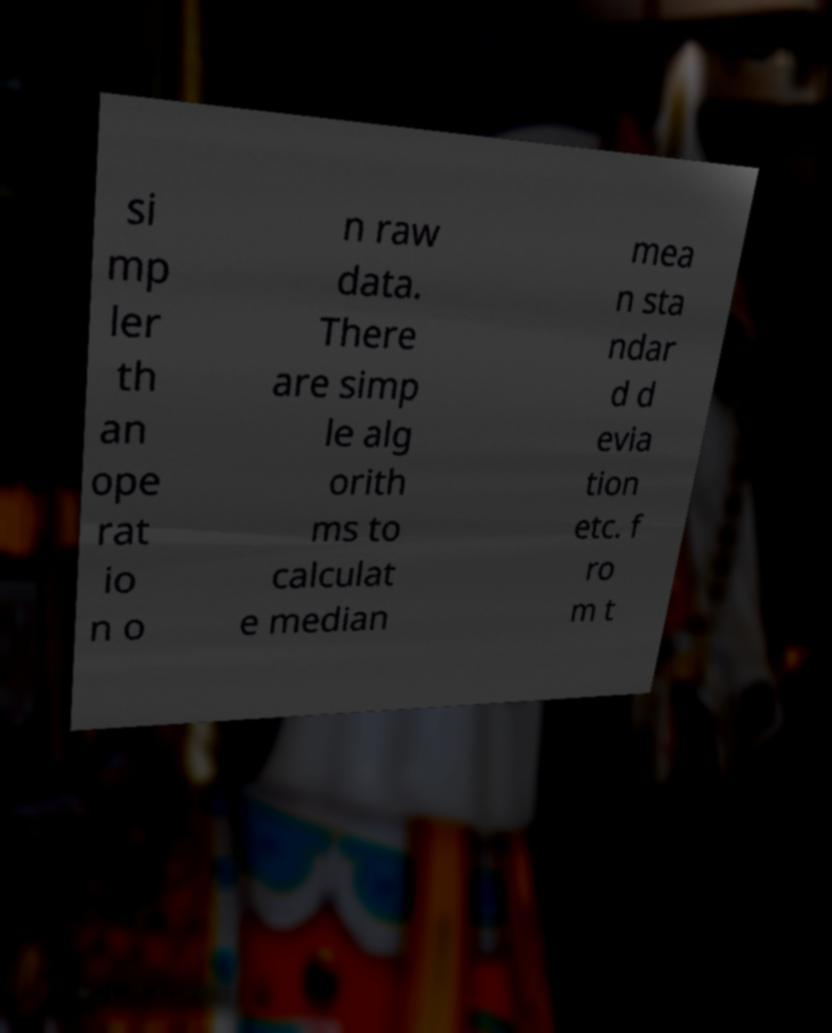There's text embedded in this image that I need extracted. Can you transcribe it verbatim? si mp ler th an ope rat io n o n raw data. There are simp le alg orith ms to calculat e median mea n sta ndar d d evia tion etc. f ro m t 